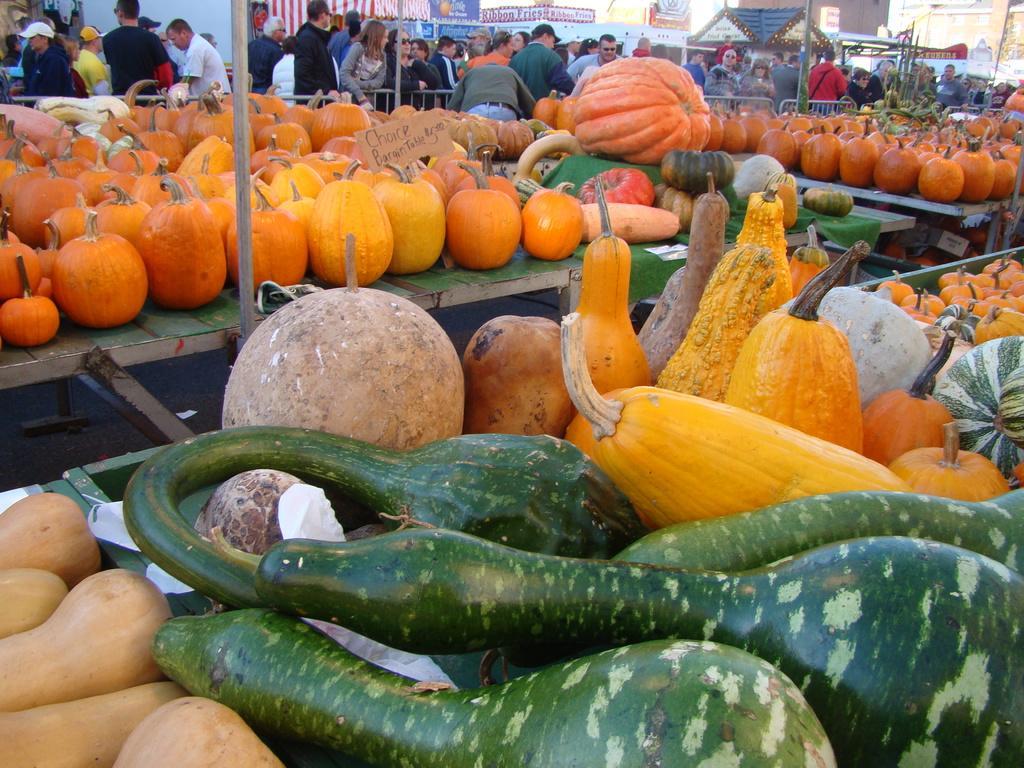Please provide a concise description of this image. In this image I can see vegetables on the table. They are in different color. Back Side I can see group of people. We can see stores. 